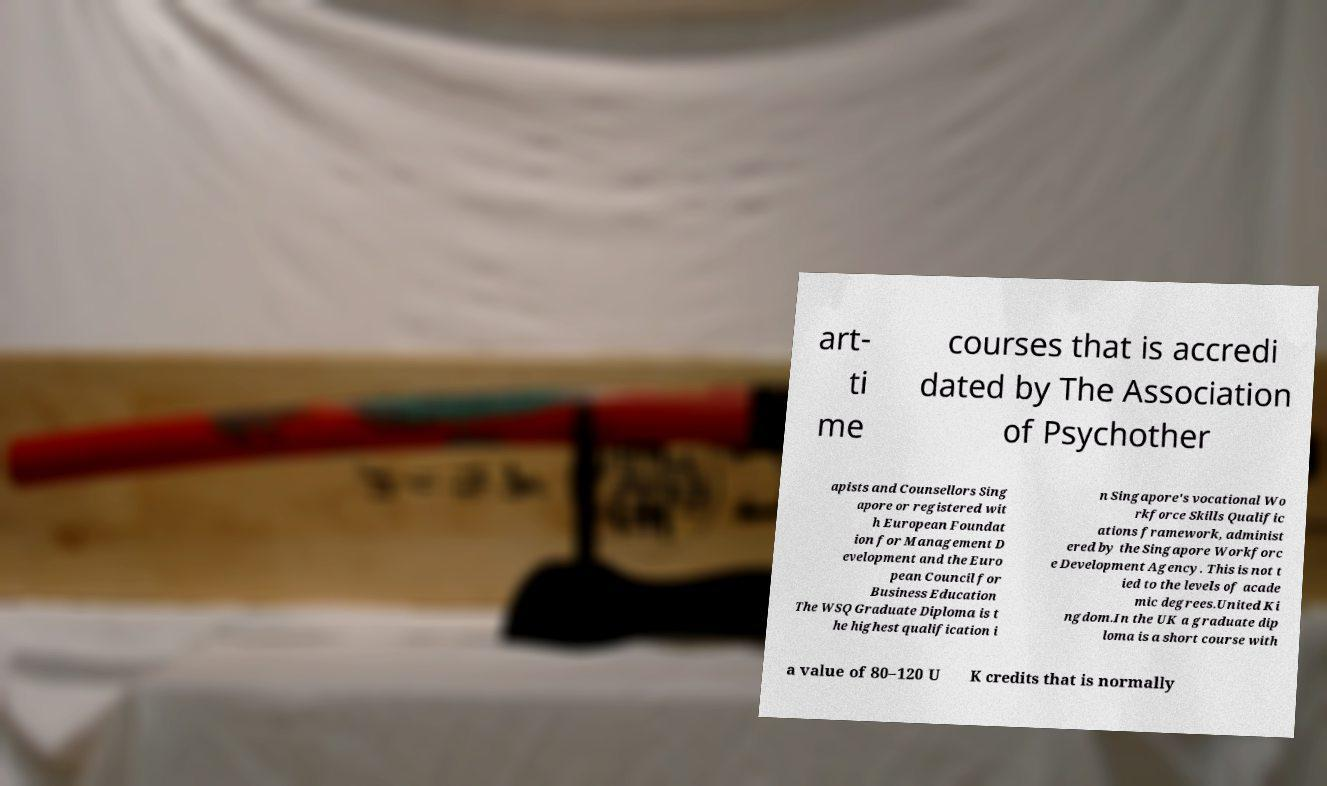I need the written content from this picture converted into text. Can you do that? art- ti me courses that is accredi dated by The Association of Psychother apists and Counsellors Sing apore or registered wit h European Foundat ion for Management D evelopment and the Euro pean Council for Business Education The WSQ Graduate Diploma is t he highest qualification i n Singapore's vocational Wo rkforce Skills Qualific ations framework, administ ered by the Singapore Workforc e Development Agency. This is not t ied to the levels of acade mic degrees.United Ki ngdom.In the UK a graduate dip loma is a short course with a value of 80–120 U K credits that is normally 